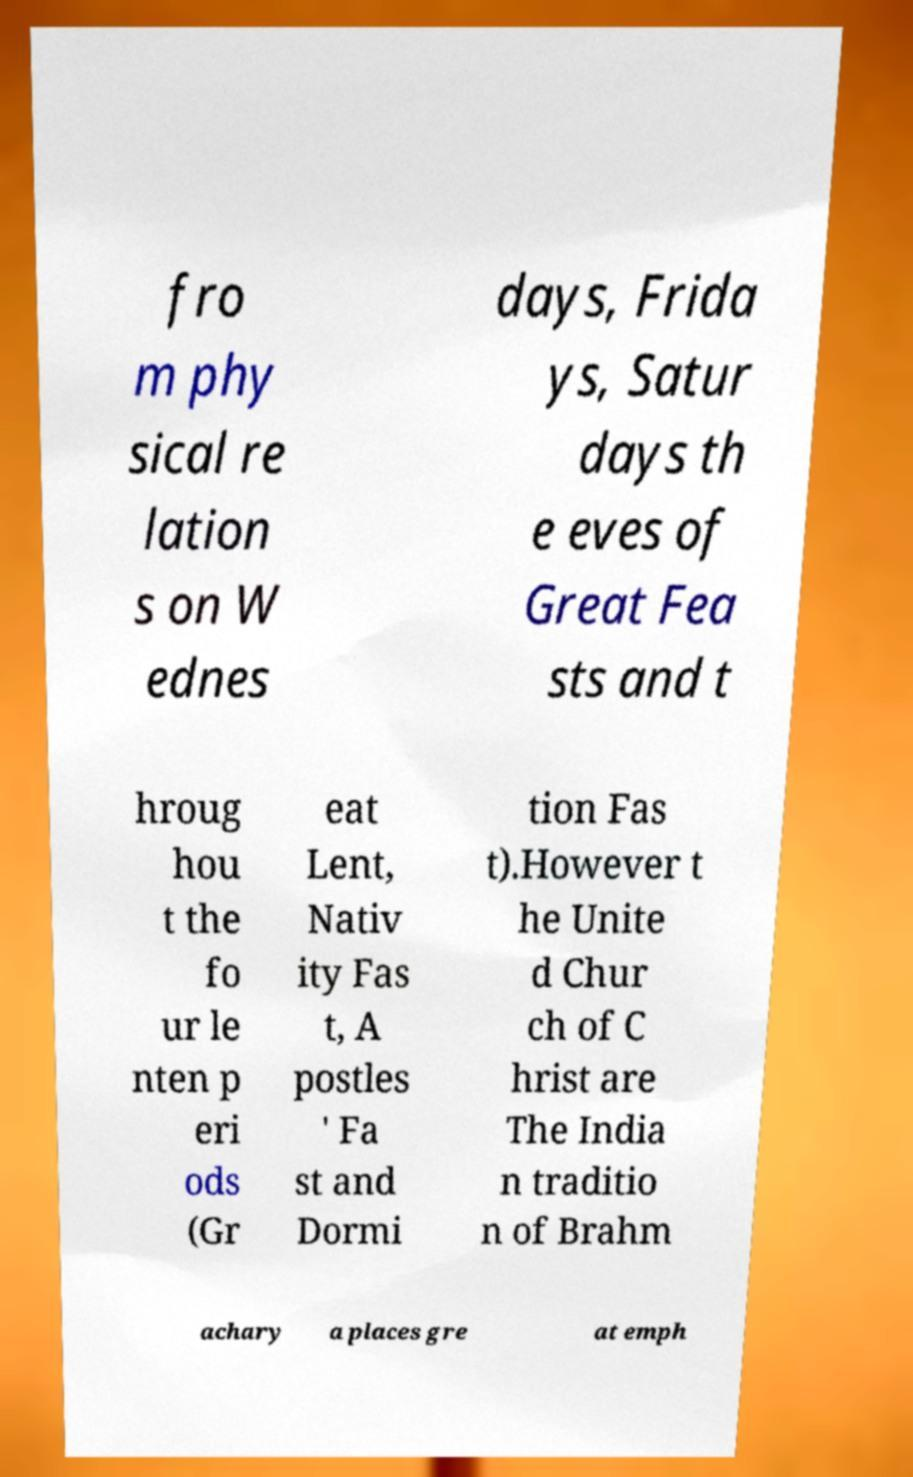Can you read and provide the text displayed in the image?This photo seems to have some interesting text. Can you extract and type it out for me? fro m phy sical re lation s on W ednes days, Frida ys, Satur days th e eves of Great Fea sts and t hroug hou t the fo ur le nten p eri ods (Gr eat Lent, Nativ ity Fas t, A postles ' Fa st and Dormi tion Fas t).However t he Unite d Chur ch of C hrist are The India n traditio n of Brahm achary a places gre at emph 